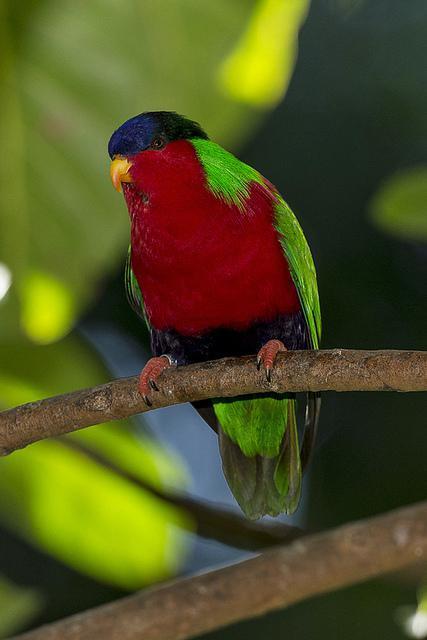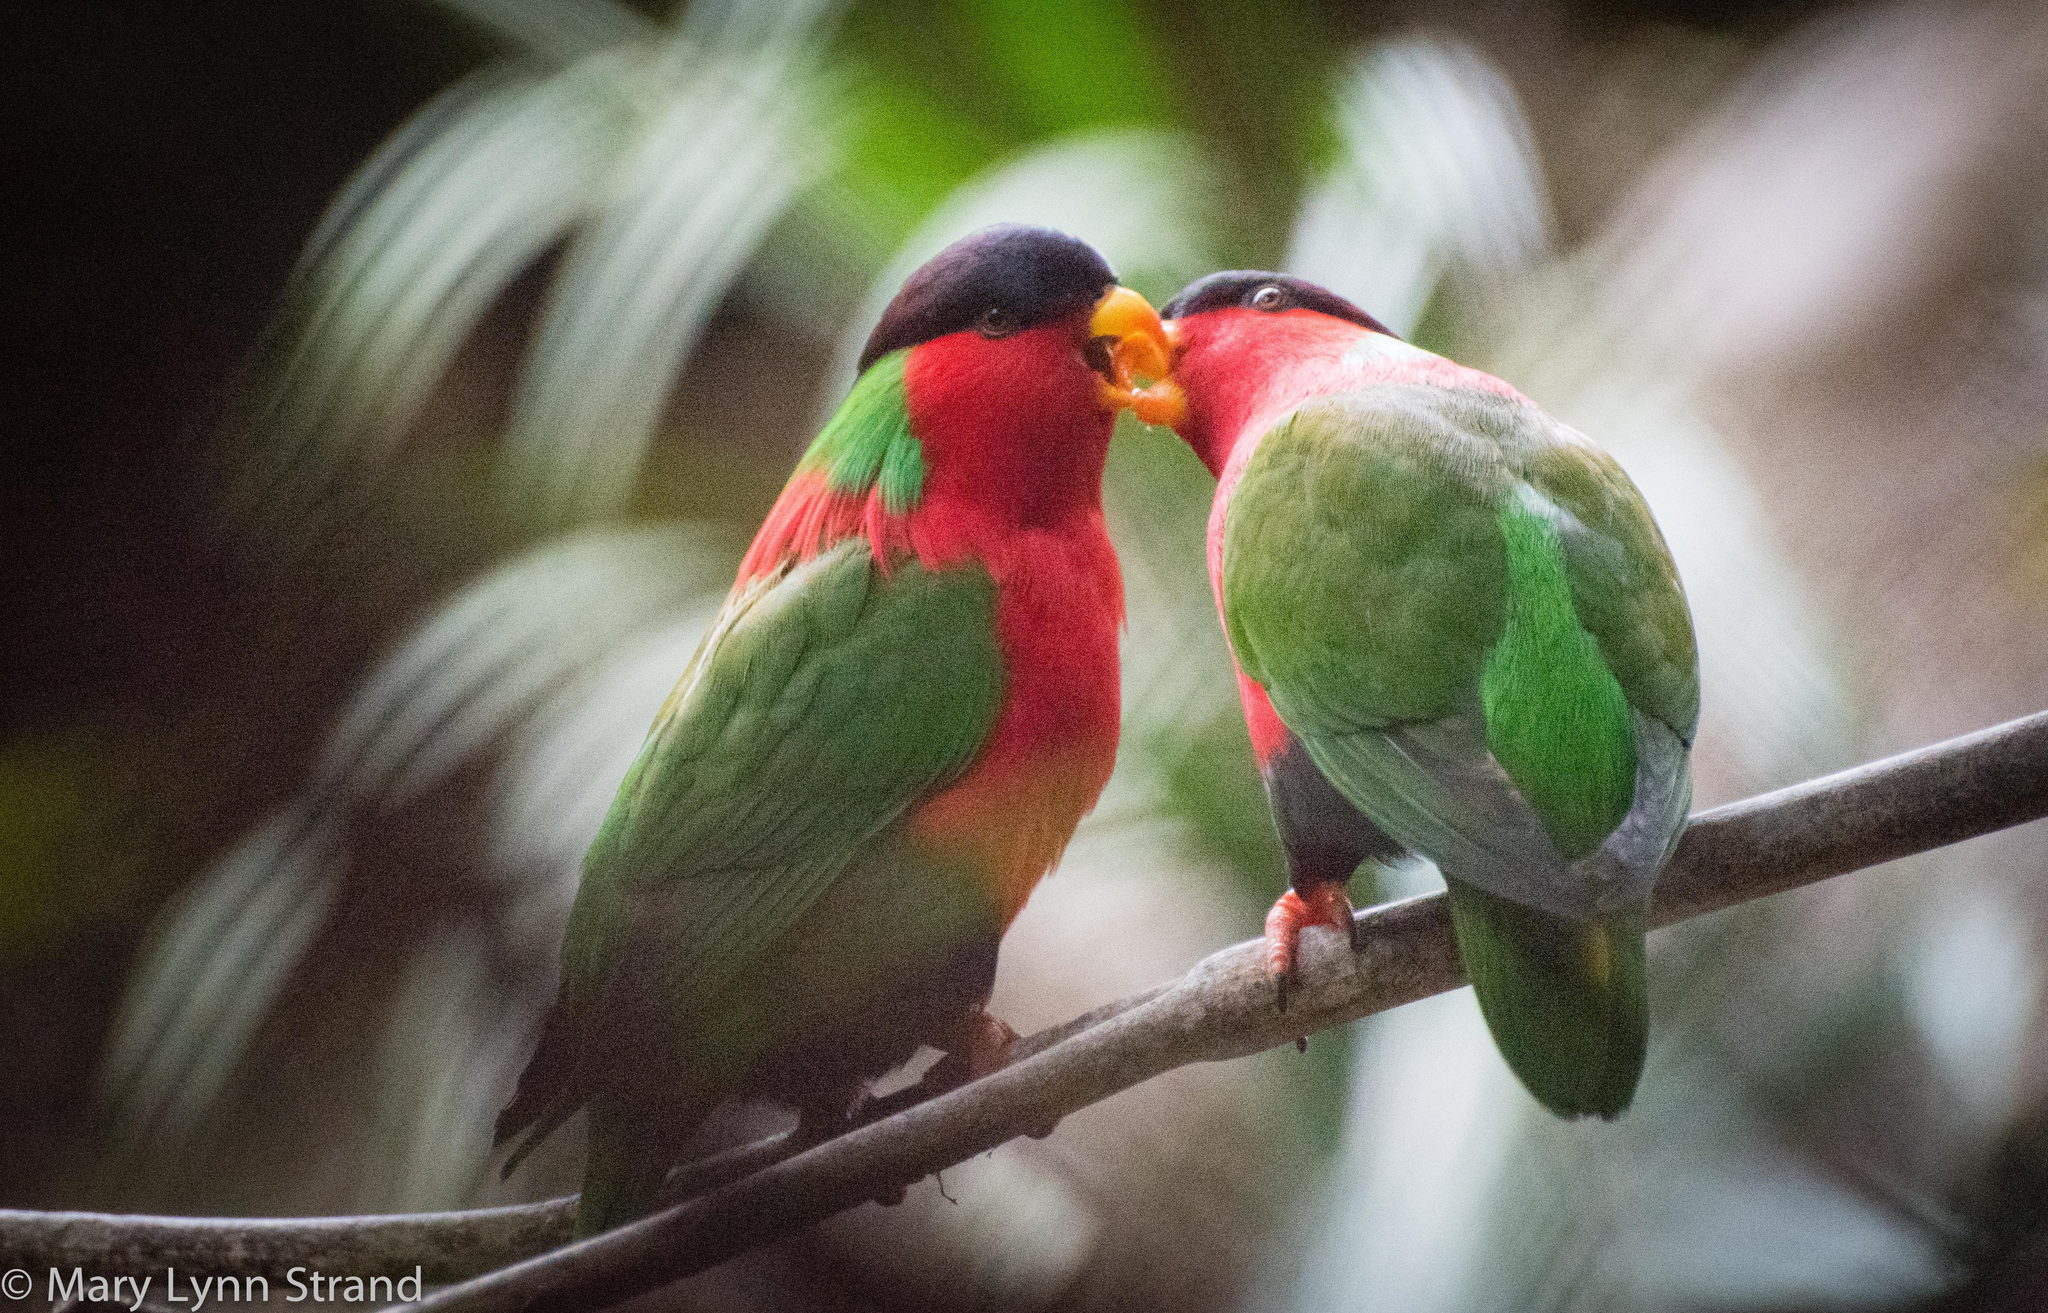The first image is the image on the left, the second image is the image on the right. Evaluate the accuracy of this statement regarding the images: "All of the images contain only one parrot.". Is it true? Answer yes or no. No. 